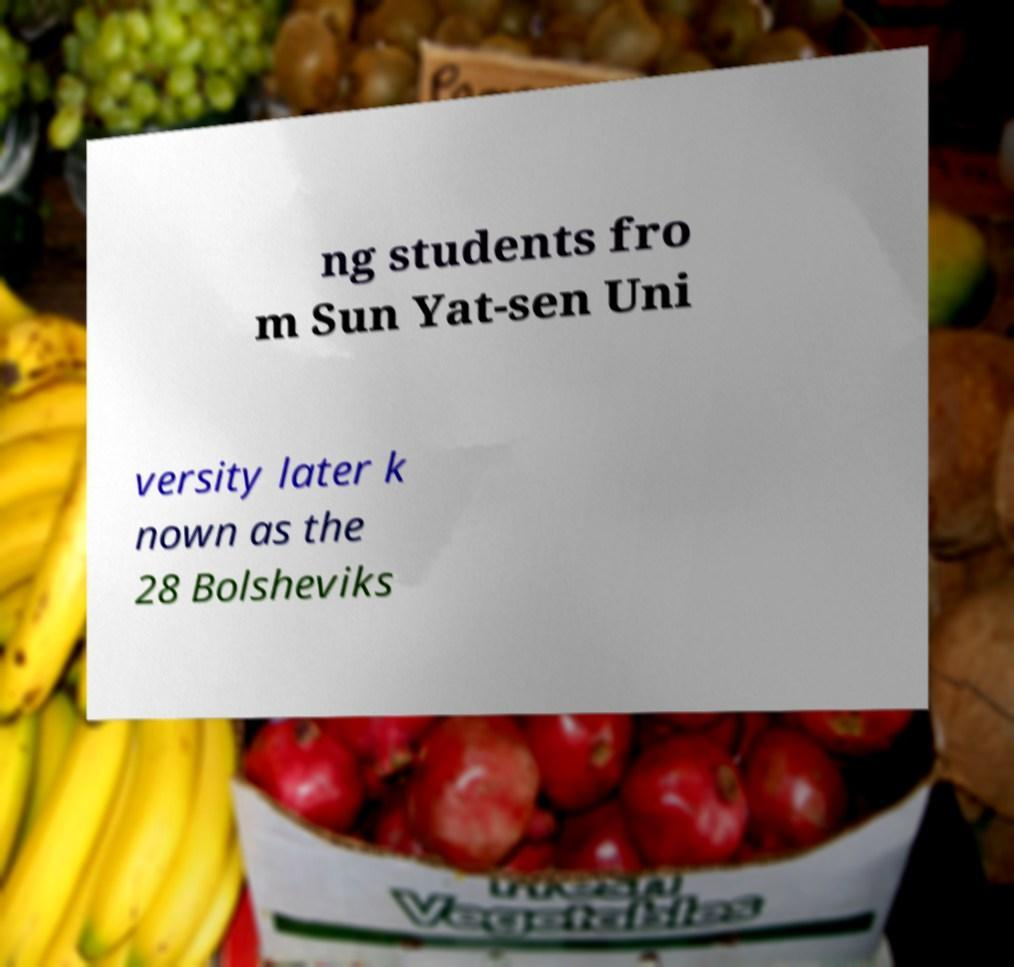Could you assist in decoding the text presented in this image and type it out clearly? ng students fro m Sun Yat-sen Uni versity later k nown as the 28 Bolsheviks 